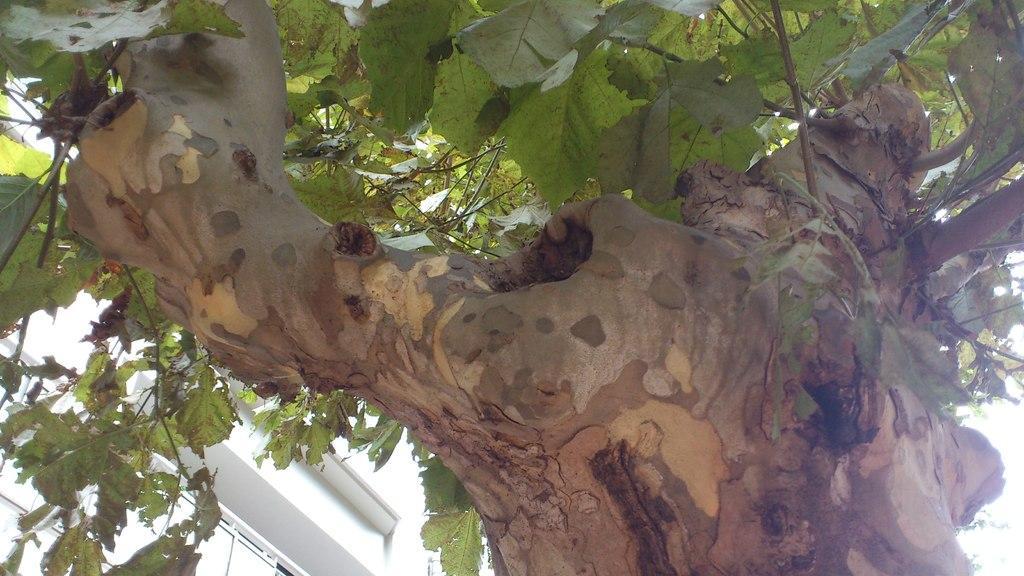Could you give a brief overview of what you see in this image? In this picture we can see a tree. 